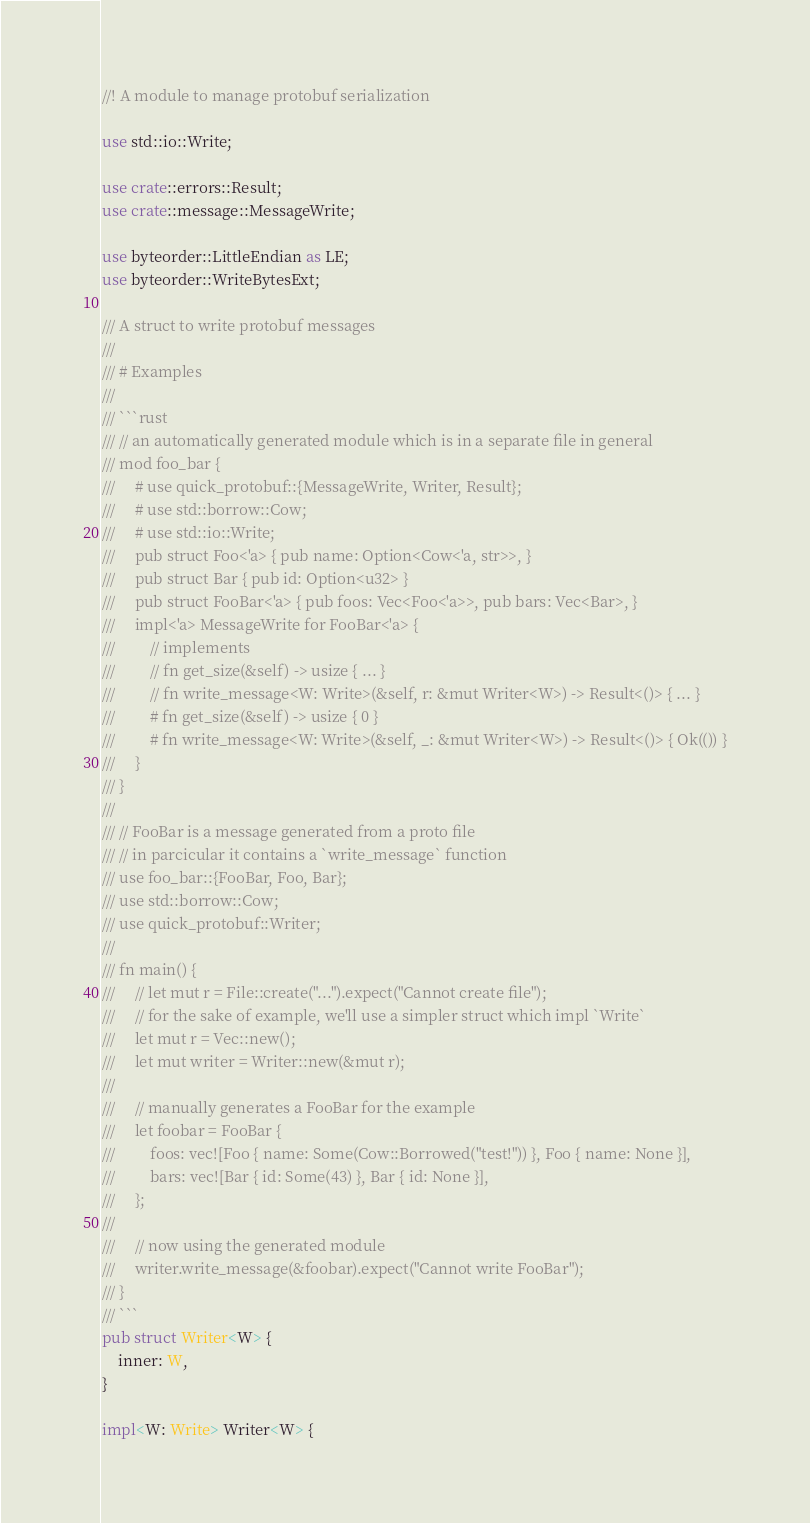<code> <loc_0><loc_0><loc_500><loc_500><_Rust_>//! A module to manage protobuf serialization

use std::io::Write;

use crate::errors::Result;
use crate::message::MessageWrite;

use byteorder::LittleEndian as LE;
use byteorder::WriteBytesExt;

/// A struct to write protobuf messages
///
/// # Examples
///
/// ```rust
/// // an automatically generated module which is in a separate file in general
/// mod foo_bar {
///     # use quick_protobuf::{MessageWrite, Writer, Result};
///     # use std::borrow::Cow;
///     # use std::io::Write;
///     pub struct Foo<'a> { pub name: Option<Cow<'a, str>>, }
///     pub struct Bar { pub id: Option<u32> }
///     pub struct FooBar<'a> { pub foos: Vec<Foo<'a>>, pub bars: Vec<Bar>, }
///     impl<'a> MessageWrite for FooBar<'a> {
///         // implements
///         // fn get_size(&self) -> usize { ... }
///         // fn write_message<W: Write>(&self, r: &mut Writer<W>) -> Result<()> { ... }
///         # fn get_size(&self) -> usize { 0 }
///         # fn write_message<W: Write>(&self, _: &mut Writer<W>) -> Result<()> { Ok(()) }
///     }
/// }
///
/// // FooBar is a message generated from a proto file
/// // in parcicular it contains a `write_message` function
/// use foo_bar::{FooBar, Foo, Bar};
/// use std::borrow::Cow;
/// use quick_protobuf::Writer;
///
/// fn main() {
///     // let mut r = File::create("...").expect("Cannot create file");
///     // for the sake of example, we'll use a simpler struct which impl `Write`
///     let mut r = Vec::new();
///     let mut writer = Writer::new(&mut r);
///
///     // manually generates a FooBar for the example
///     let foobar = FooBar {
///         foos: vec![Foo { name: Some(Cow::Borrowed("test!")) }, Foo { name: None }],
///         bars: vec![Bar { id: Some(43) }, Bar { id: None }],
///     };
///
///     // now using the generated module
///     writer.write_message(&foobar).expect("Cannot write FooBar");
/// }
/// ```
pub struct Writer<W> {
    inner: W,
}

impl<W: Write> Writer<W> {</code> 